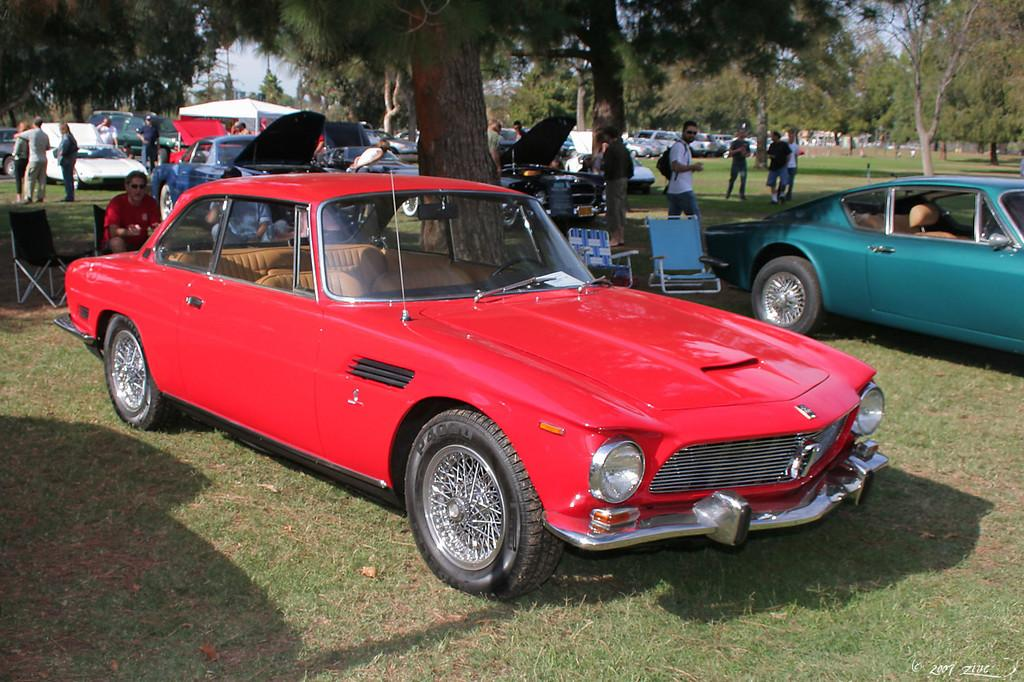What types of objects are in the image? There are vehicles, chairs, people, trees, and other objects in the image. How many different colors can be seen on the vehicles? The vehicles have different colors. What are the people in the image doing? Some people are sitting on the chairs. What else can be seen in the image besides the vehicles and chairs? Trees are present in the image. What type of corn is being served on the coach in the image? There is no corn or coach present in the image. Can you tell me how many cards are being held by the people in the image? There is no mention of cards or people holding cards in the image. 